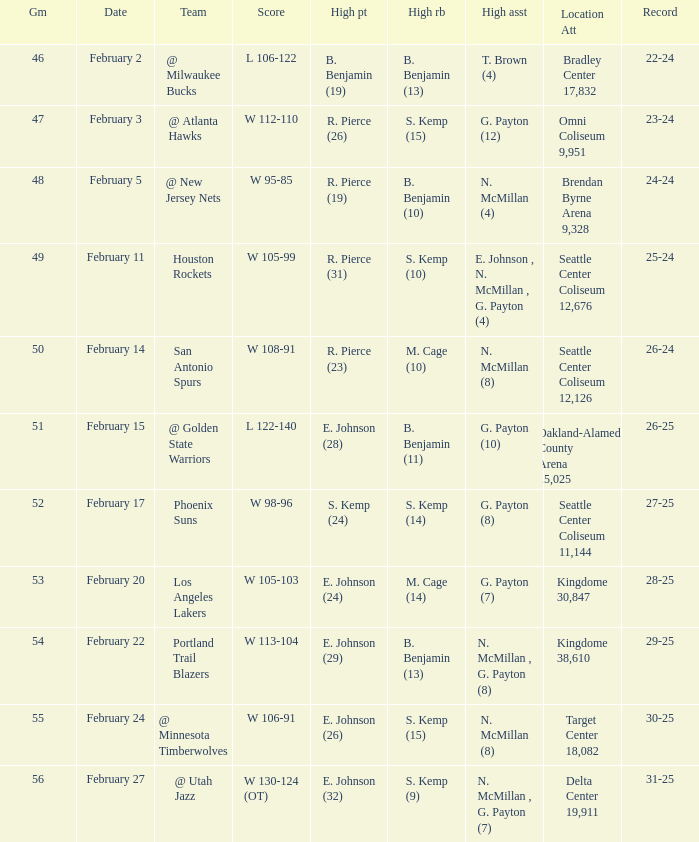What dated was the game played at the location delta center 19,911? February 27. 